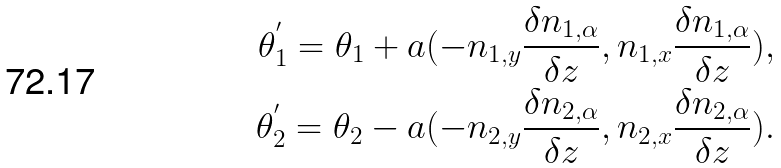<formula> <loc_0><loc_0><loc_500><loc_500>\theta ^ { ^ { \prime } } _ { 1 } = \theta _ { 1 } + a ( - n _ { 1 , y } \frac { \delta n _ { 1 , \alpha } } { \delta z } , n _ { 1 , x } \frac { \delta n _ { 1 , \alpha } } { \delta z } ) , \\ \theta ^ { ^ { \prime } } _ { 2 } = \theta _ { 2 } - a ( - n _ { 2 , y } \frac { \delta n _ { 2 , \alpha } } { \delta z } , n _ { 2 , x } \frac { \delta n _ { 2 , \alpha } } { \delta z } ) .</formula> 